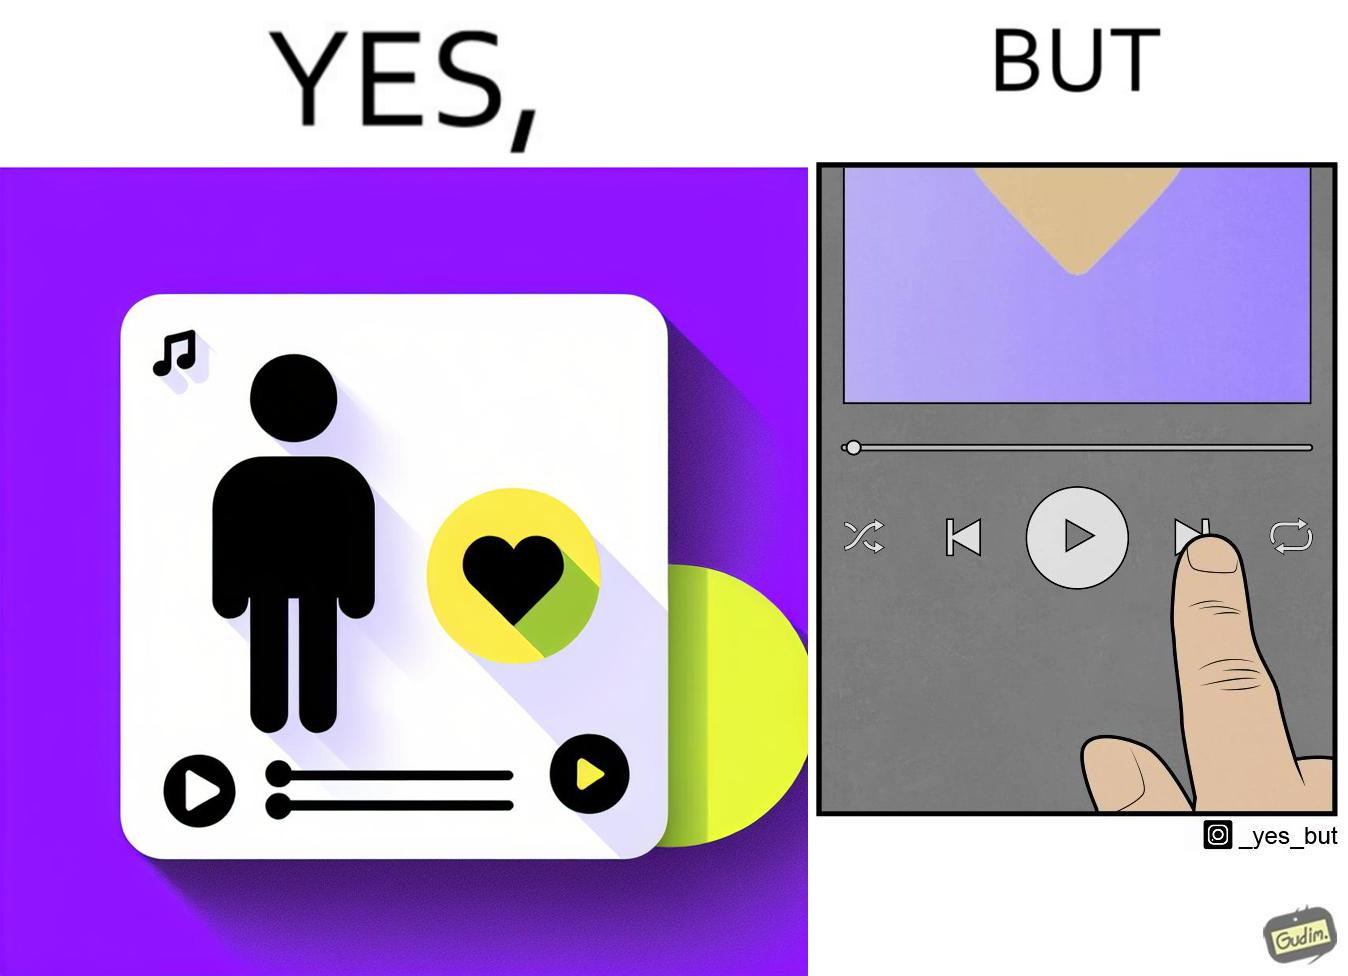Is this image satirical or non-satirical? Yes, this image is satirical. 